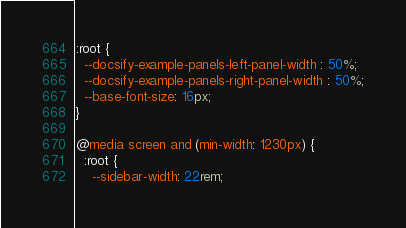Convert code to text. <code><loc_0><loc_0><loc_500><loc_500><_CSS_>:root {
  --docsify-example-panels-left-panel-width : 50%;
  --docsify-example-panels-right-panel-width : 50%;
  --base-font-size: 16px;
}

@media screen and (min-width: 1230px) {
  :root {
    --sidebar-width: 22rem;</code> 